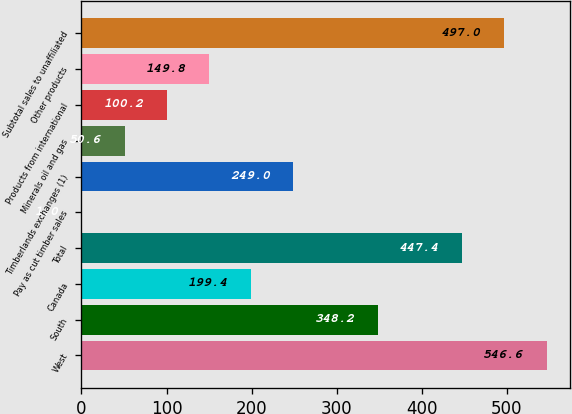<chart> <loc_0><loc_0><loc_500><loc_500><bar_chart><fcel>West<fcel>South<fcel>Canada<fcel>Total<fcel>Pay as cut timber sales<fcel>Timberlands exchanges (1)<fcel>Minerals oil and gas<fcel>Products from international<fcel>Other products<fcel>Subtotal sales to unaffiliated<nl><fcel>546.6<fcel>348.2<fcel>199.4<fcel>447.4<fcel>1<fcel>249<fcel>50.6<fcel>100.2<fcel>149.8<fcel>497<nl></chart> 